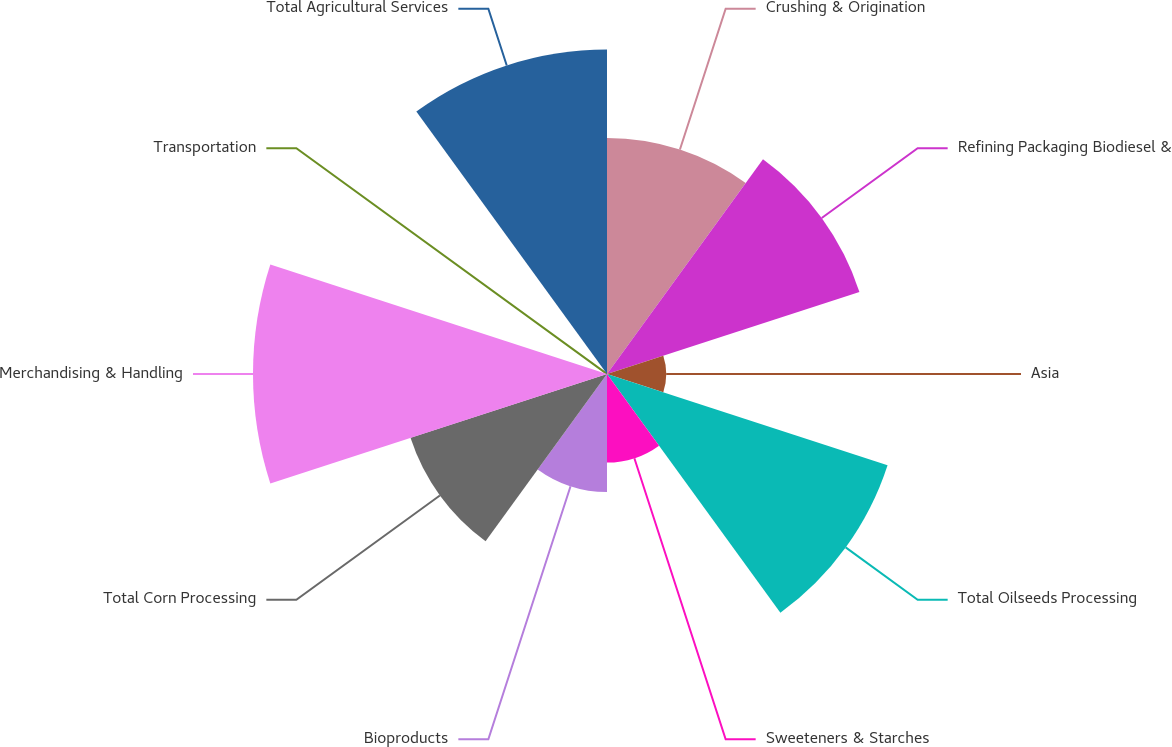<chart> <loc_0><loc_0><loc_500><loc_500><pie_chart><fcel>Crushing & Origination<fcel>Refining Packaging Biodiesel &<fcel>Asia<fcel>Total Oilseeds Processing<fcel>Sweeteners & Starches<fcel>Bioproducts<fcel>Total Corn Processing<fcel>Merchandising & Handling<fcel>Transportation<fcel>Total Agricultural Services<nl><fcel>12.12%<fcel>13.63%<fcel>3.04%<fcel>15.15%<fcel>4.55%<fcel>6.06%<fcel>10.61%<fcel>18.18%<fcel>0.01%<fcel>16.66%<nl></chart> 